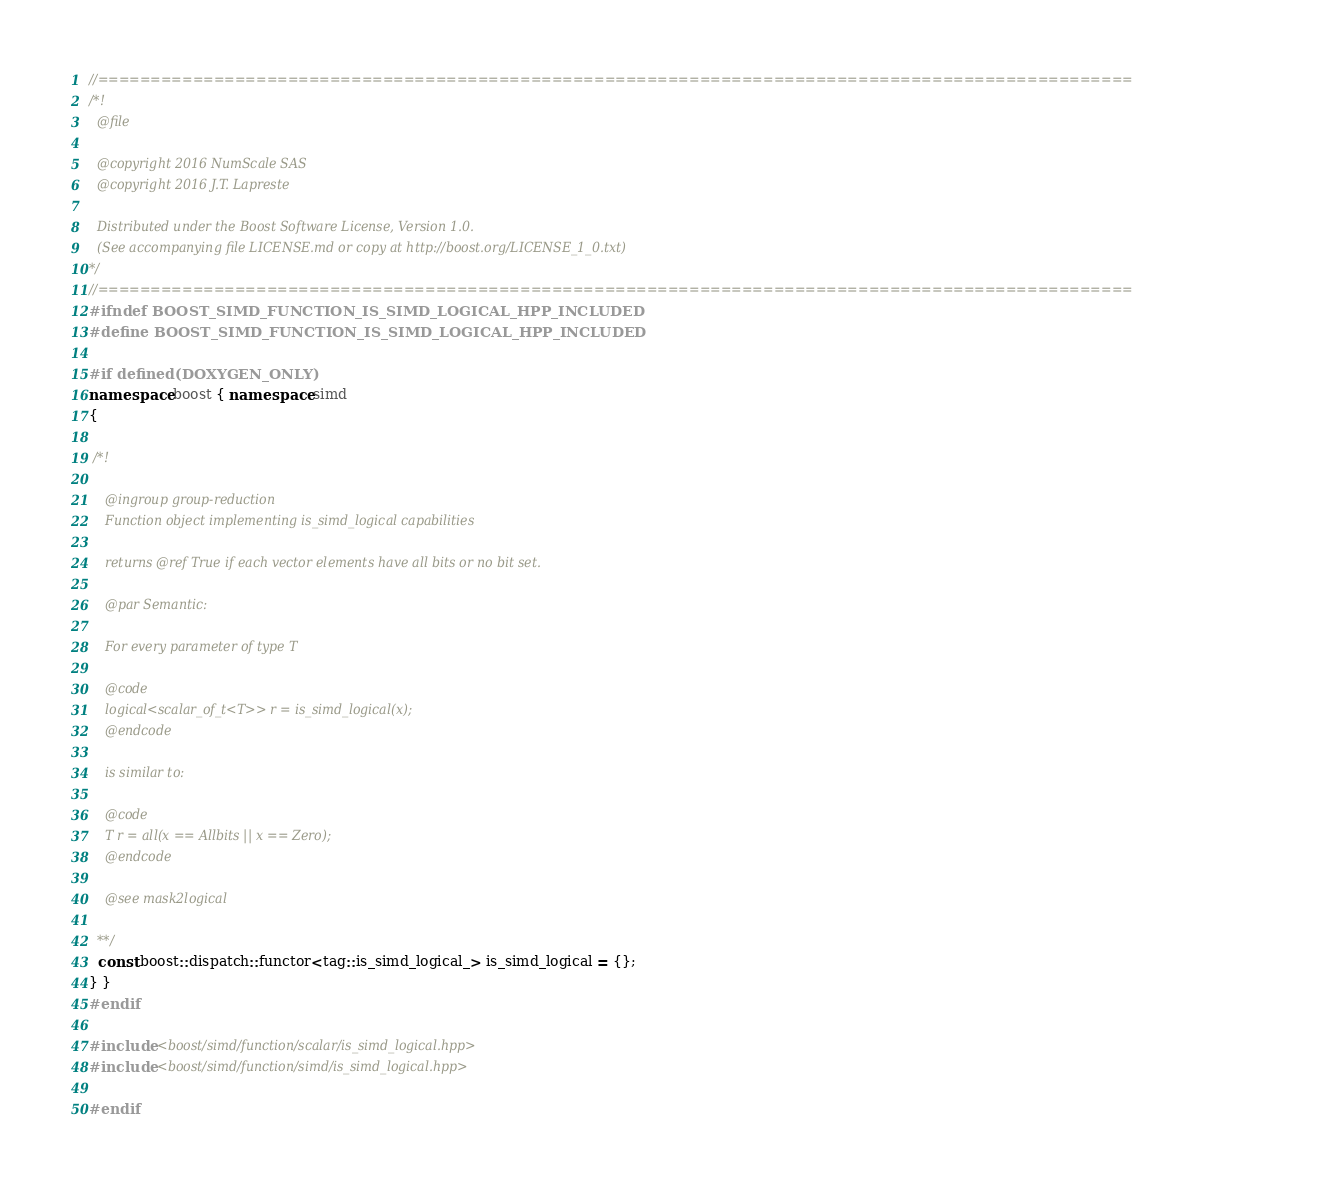<code> <loc_0><loc_0><loc_500><loc_500><_C++_>//==================================================================================================
/*!
  @file

  @copyright 2016 NumScale SAS
  @copyright 2016 J.T. Lapreste

  Distributed under the Boost Software License, Version 1.0.
  (See accompanying file LICENSE.md or copy at http://boost.org/LICENSE_1_0.txt)
*/
//==================================================================================================
#ifndef BOOST_SIMD_FUNCTION_IS_SIMD_LOGICAL_HPP_INCLUDED
#define BOOST_SIMD_FUNCTION_IS_SIMD_LOGICAL_HPP_INCLUDED

#if defined(DOXYGEN_ONLY)
namespace boost { namespace simd
{

 /*!

    @ingroup group-reduction
    Function object implementing is_simd_logical capabilities

    returns @ref True if each vector elements have all bits or no bit set.

    @par Semantic:

    For every parameter of type T

    @code
    logical<scalar_of_t<T>> r = is_simd_logical(x);
    @endcode

    is similar to:

    @code
    T r = all(x == Allbits || x == Zero);
    @endcode

    @see mask2logical

  **/
  const boost::dispatch::functor<tag::is_simd_logical_> is_simd_logical = {};
} }
#endif

#include <boost/simd/function/scalar/is_simd_logical.hpp>
#include <boost/simd/function/simd/is_simd_logical.hpp>

#endif
</code> 